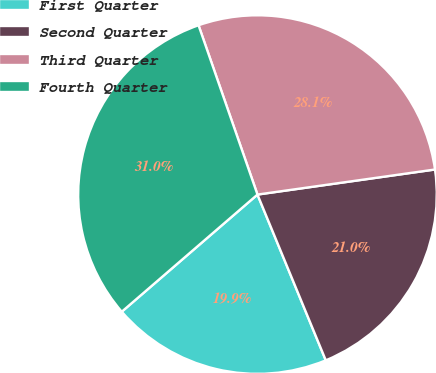Convert chart. <chart><loc_0><loc_0><loc_500><loc_500><pie_chart><fcel>First Quarter<fcel>Second Quarter<fcel>Third Quarter<fcel>Fourth Quarter<nl><fcel>19.89%<fcel>21.01%<fcel>28.1%<fcel>31.0%<nl></chart> 